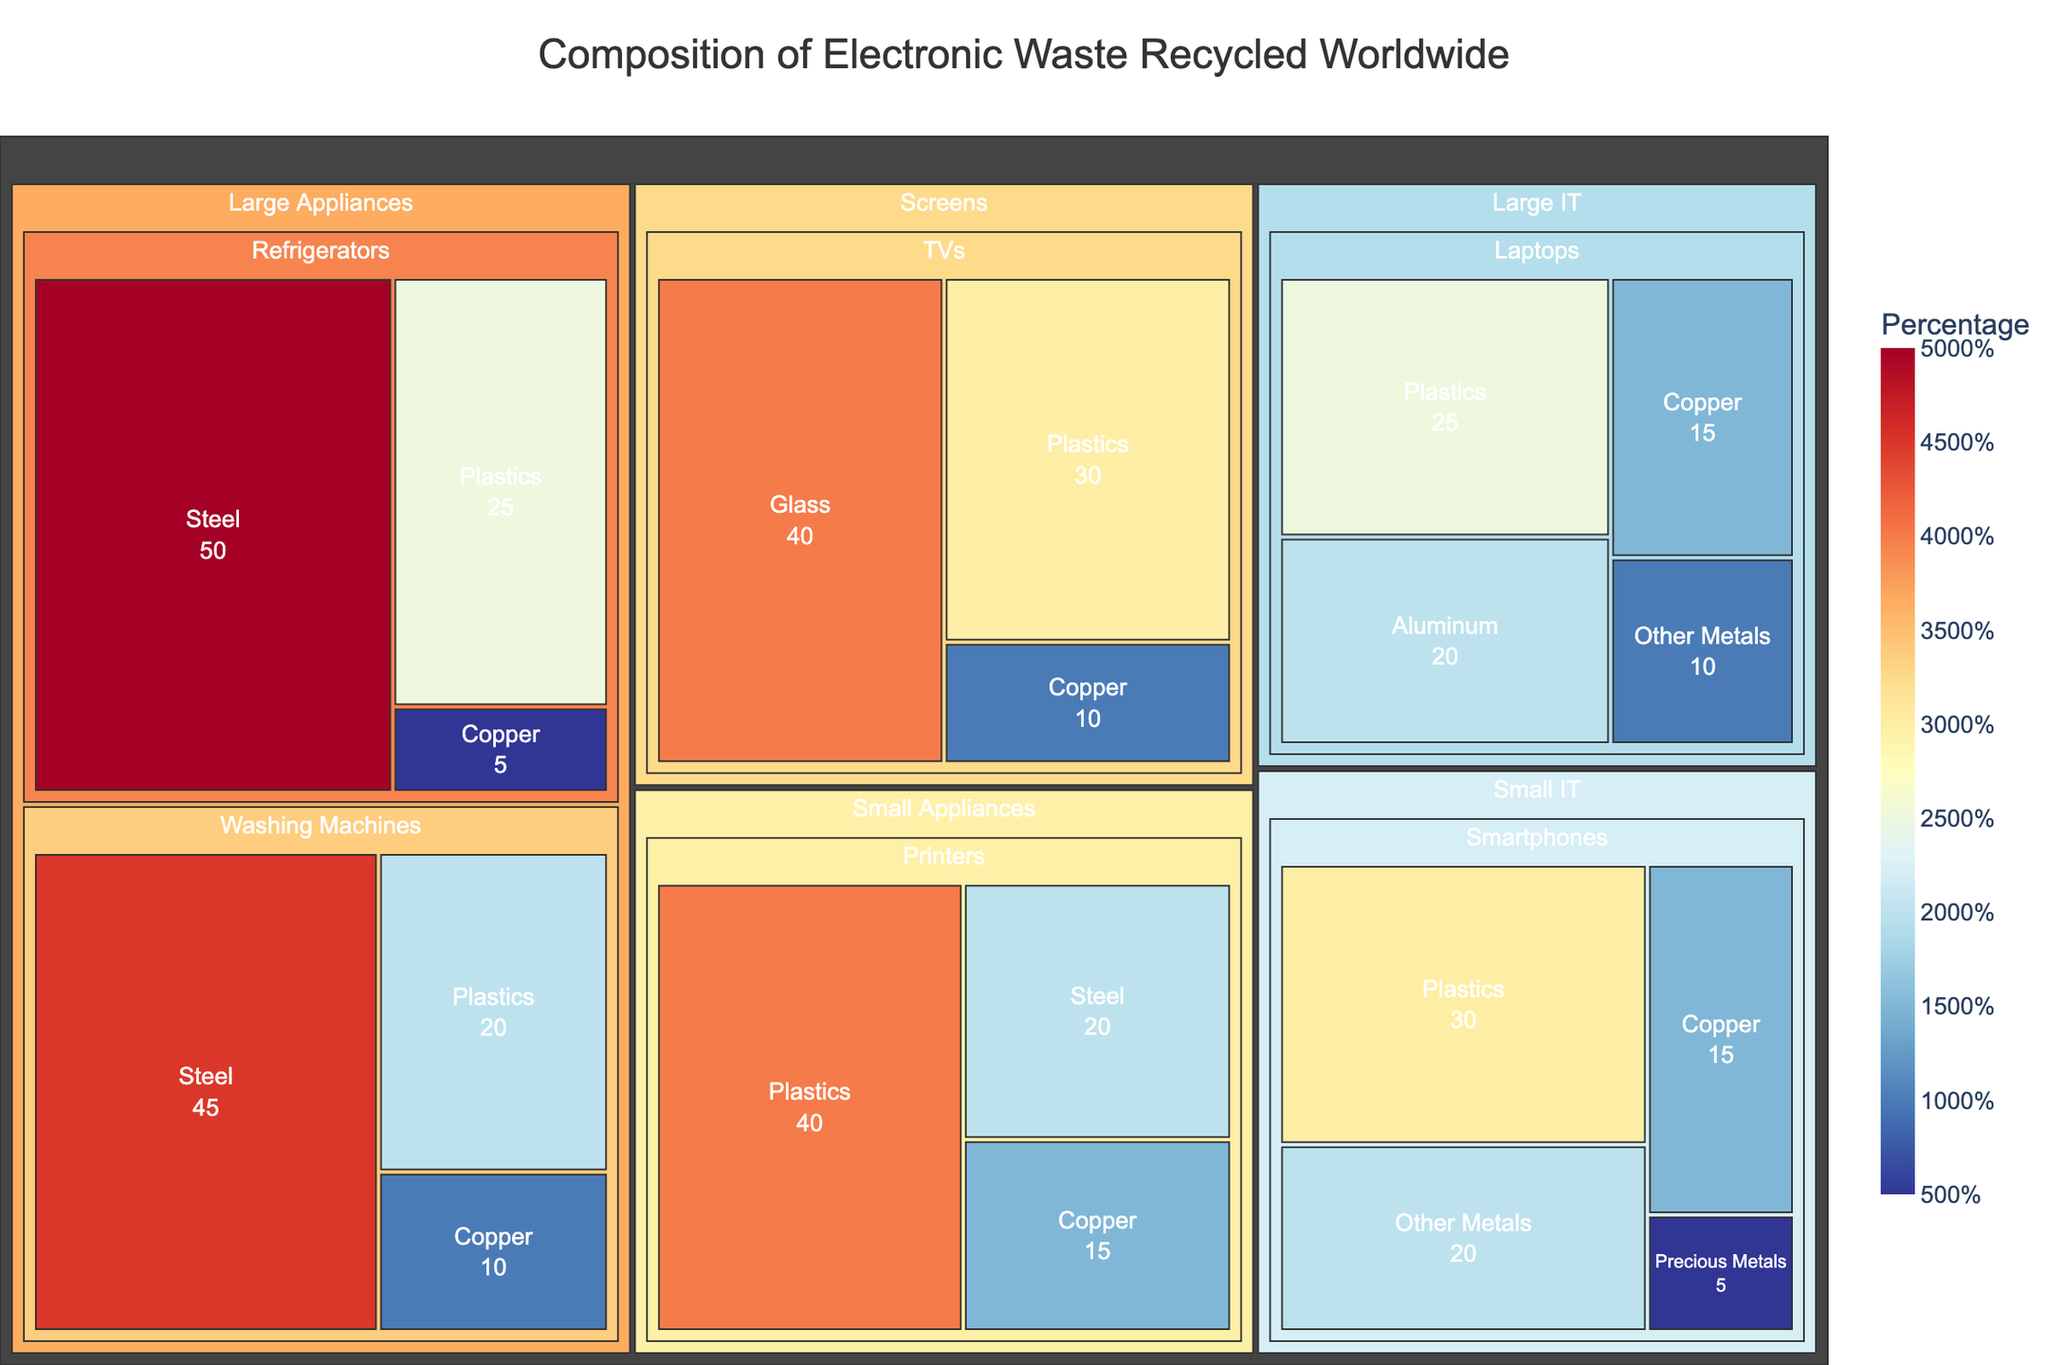What's the title of the treemap? The title of the treemap is displayed at the top of the figure. It helps to understand what the figure is representing.
Answer: Composition of Electronic Waste Recycled Worldwide Which device category contains the largest percentage of plastic? Identify the plastic percentage within each device category and compare them.
Answer: Small IT What is the total percentage of steel found in household appliances? Sum the percentage of steel in refrigerators and washing machines.
Answer: 95% Which device has the smallest percentage of copper content? Check the copper content for each device and identify the smallest value.
Answer: Refrigerators Which material has the largest percentage share in TVs? Identify the percentage share of each material within the TV device category.
Answer: Glass How does the plastic percentage in printers compare to the plastic percentage in smartphones? Compare the percentage of plastics between printers and smartphones.
Answer: Printers have a higher percentage of plastics than smartphones What's the combined percentage of precious metals in all IT devices? Sum the percentage of precious metals in all devices under the IT category.
Answer: 5% Which device type contributes most significantly to the copper percentage in Small IT category? Identify the device within the Small IT category with the highest copper percentage.
Answer: Smartphones What percentage of materials used in refrigerators are non-metal based? Subtract the percentage of metallic materials from the total for refrigerators.
Answer: 25% If we merge the Large IT and Screens categories, what is the average plastic percentage? Calculate the weighted average percentage of plastics for Large IT and Screens categories.
Answer: 27.5% 